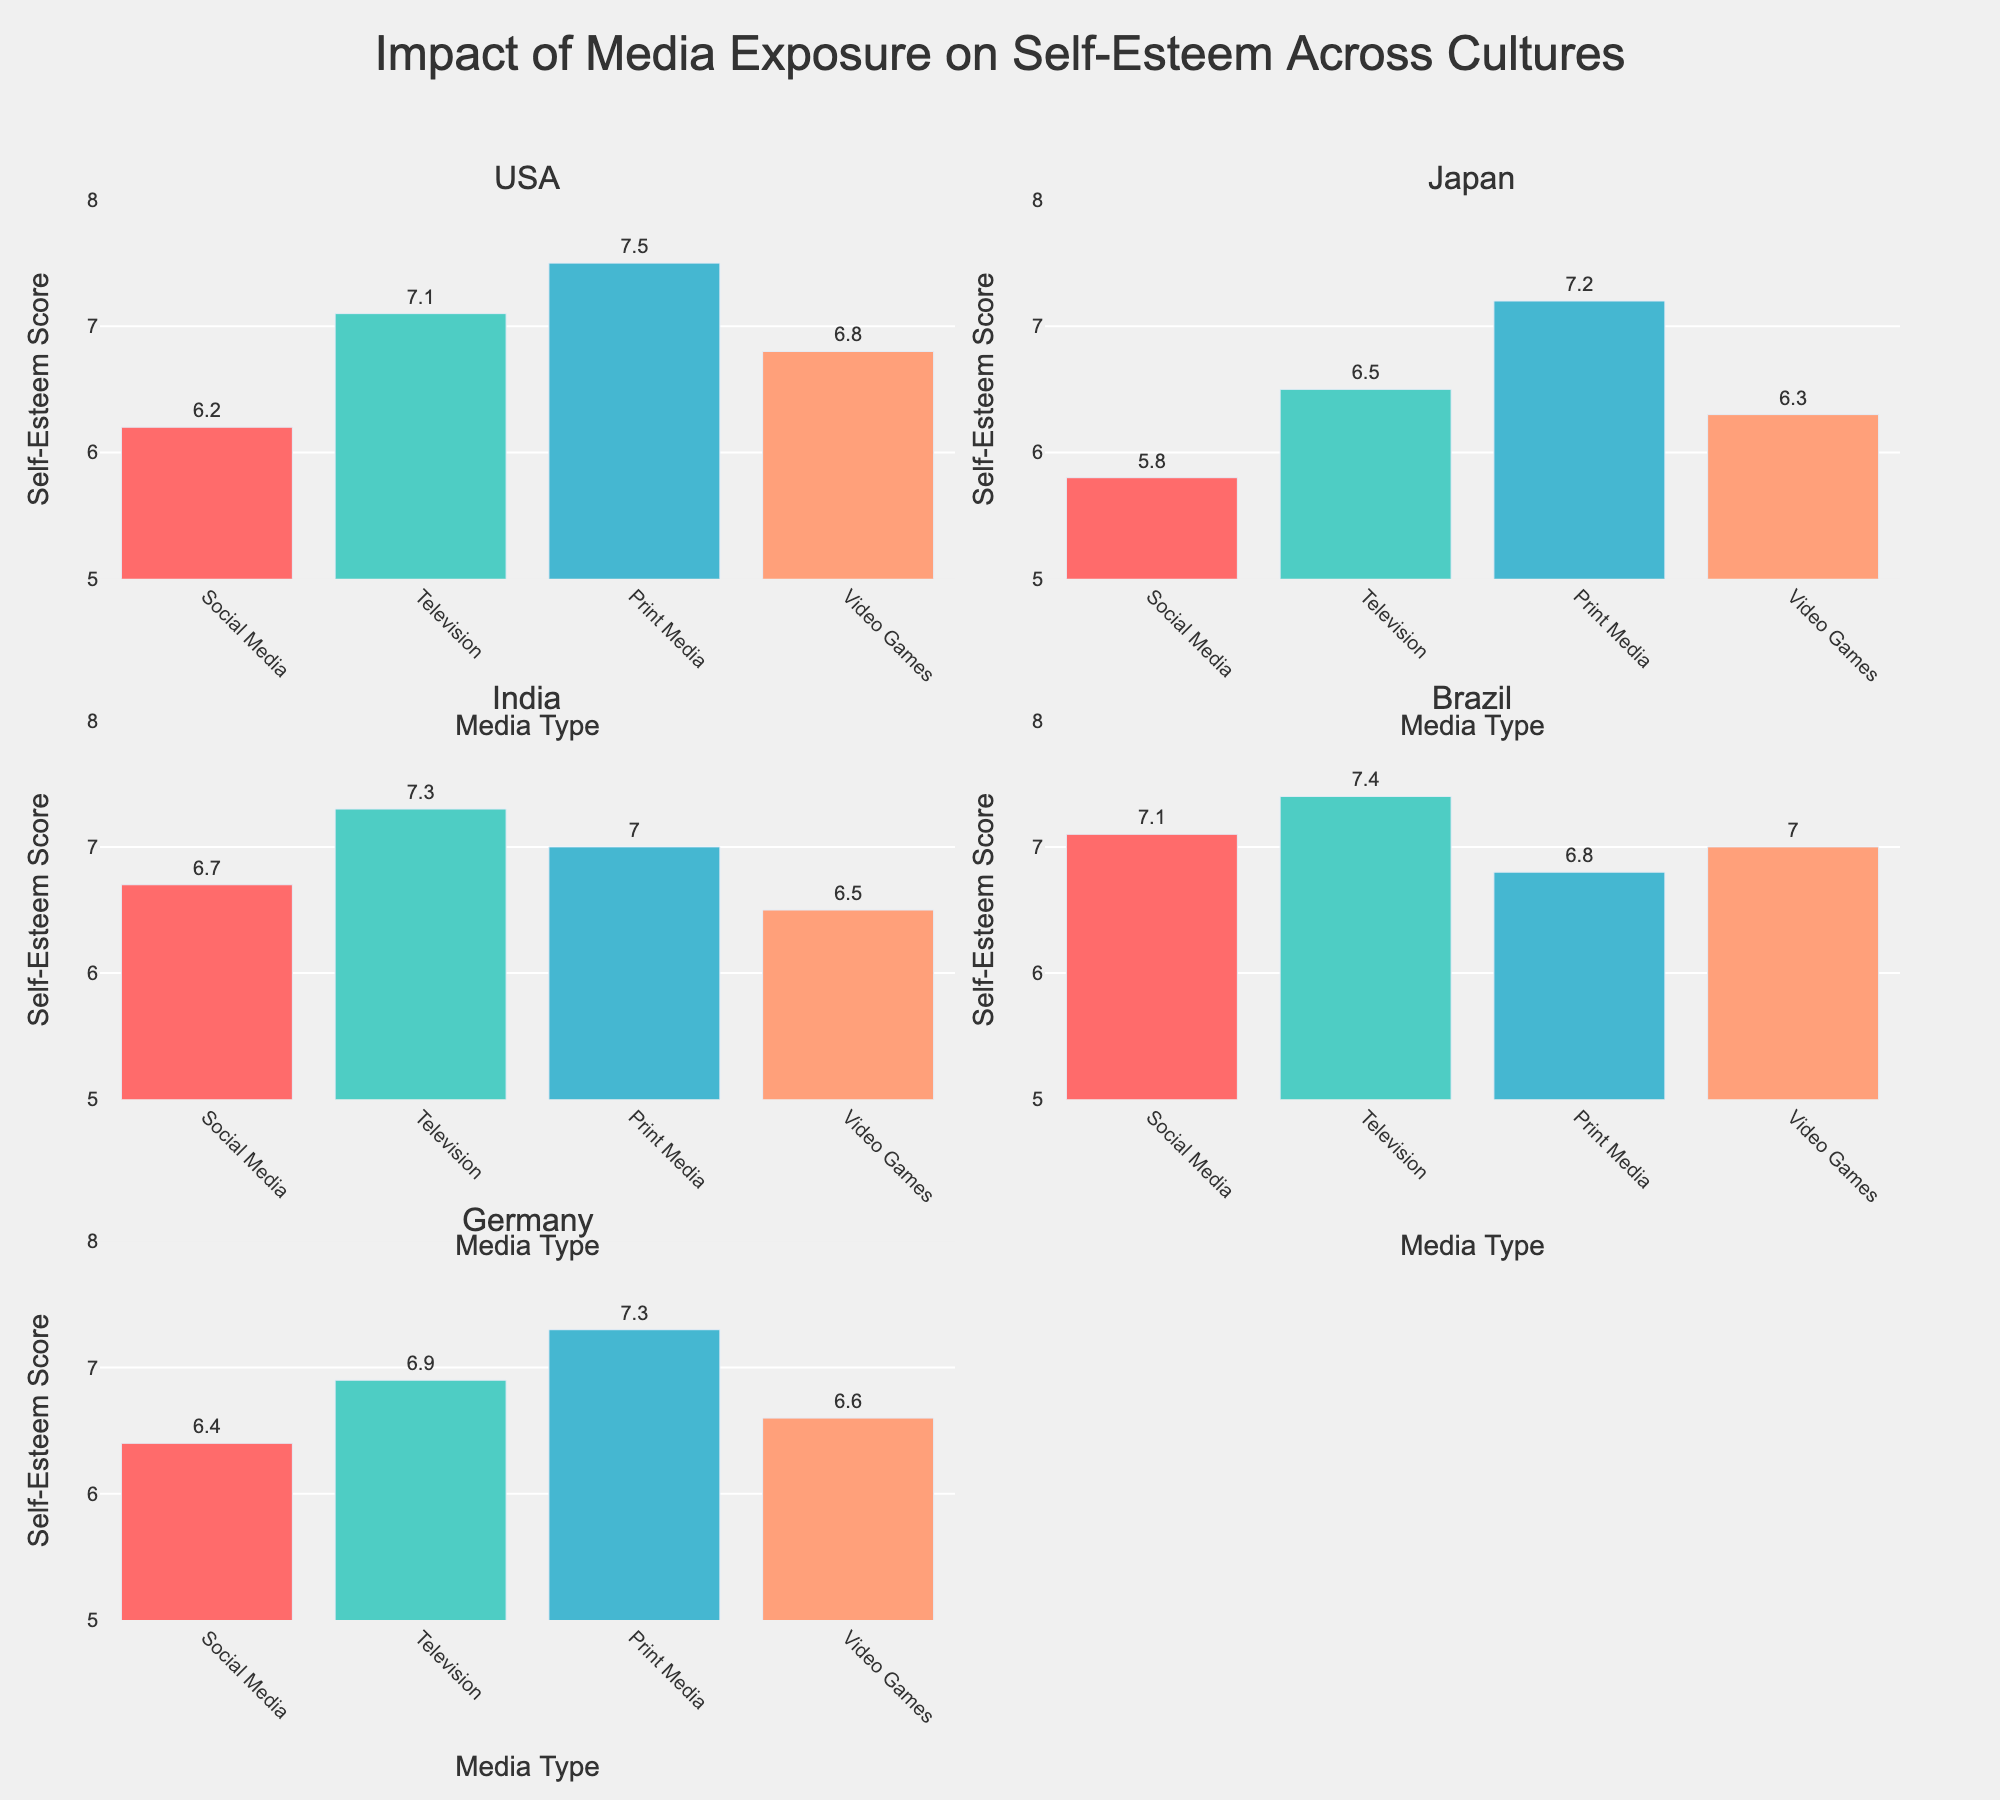What is the average temperature in Kingston for the months shown? The temperatures for Kingston in the months provided are 26°C (Jan), 27°C (Apr), 29°C (Jul), and 28°C (Oct). To find the average, sum these values and divide by the number of months: (26 + 27 + 29 + 28) / 4 = 110 / 4
Answer: 27.5°C Which city experiences the highest rainfall in October? To find this, compare the rainfall values for October in each city: Kingston (147 mm), Montego Bay (229 mm), Spanish Town (153 mm), Portmore (150 mm), and Mandeville (245 mm). The city with the highest value is Mandeville with 245 mm.
Answer: Mandeville How does the rainfall in Montego Bay during January compare to the rainfall in Kingston during the same month? The rainfall in January for Montego Bay is 91 mm, whereas for Kingston it is 23 mm. Therefore, Montego Bay receives more rainfall than Kingston in January.
Answer: Montego Bay receives more What is the average rainfall for Spanish Town across the given months? The rainfall values for Spanish Town in the provided months are 25 mm (Jan), 58 mm (Apr), 70 mm (Jul), and 153 mm (Oct). To find the average, sum these values and divide by the number of months: (25 + 58 + 70 + 153) / 4 = 306 / 4
Answer: 76.5 mm Which city shows the highest average temperature across the year? To find this, compute the average temperature for each city. Kingston: (26 + 27 + 29 + 28) / 4 = 27.5°C, Montego Bay: (25 + 26 + 28 + 27) / 4 = 26.5°C, Spanish Town: (25 + 26 + 28 + 27) / 4 = 26.5°C, Portmore: (26 + 27 + 29 + 28) / 4 = 27.5°C, Mandeville: (22 + 23 + 25 + 24) / 4 = 23.5°C. Both Kingston and Portmore have the highest average at 27.5°C.
Answer: Kingston and Portmore Which month witnesses the maximum rainfall in Mandeville? By examining the rainfall values for Mandeville, we see that January has 101 mm, April has 162 mm, July has 131 mm, and October has 245 mm. Thus, the maximum rainfall occurs in October.
Answer: October How does the average temperature in Mandeville in January compare with the average temperature in Montego Bay in the same month? The average temperature in Mandeville in January is 22°C, while in Montego Bay it is 25°C. Montego Bay has a higher temperature than Mandeville in January.
Answer: Montego Bay is higher How much more rainfall does Portmore receive in April compared to January? Portmore's rainfall in April is 55 mm and in January it is 24 mm. The difference is 55 mm - 24 mm.
Answer: 31 mm What is the temperature range observed for Portmore across the year? The temperatures for Portmore are 26°C (Jan), 27°C (Apr), 29°C (Jul), and 28°C (Oct). The range is the difference between the highest and lowest values: 29°C - 26°C.
Answer: 3°C 